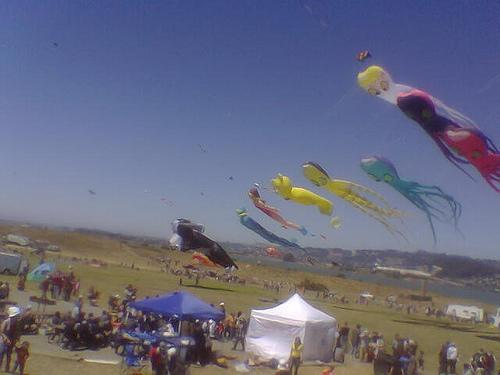What type of structures are shown? Please explain your reasoning. tent. The structures are tents. 